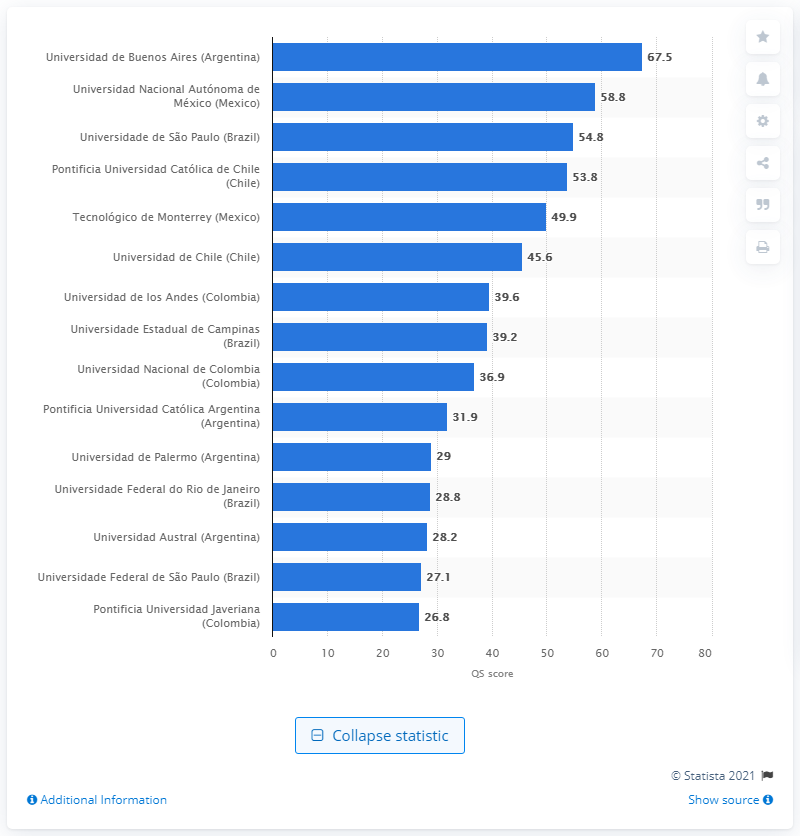Mention a couple of crucial points in this snapshot. The score of Universidad Autónoma de México was 58.8. The score of the Universidad Autónoma de México was 58.8. 